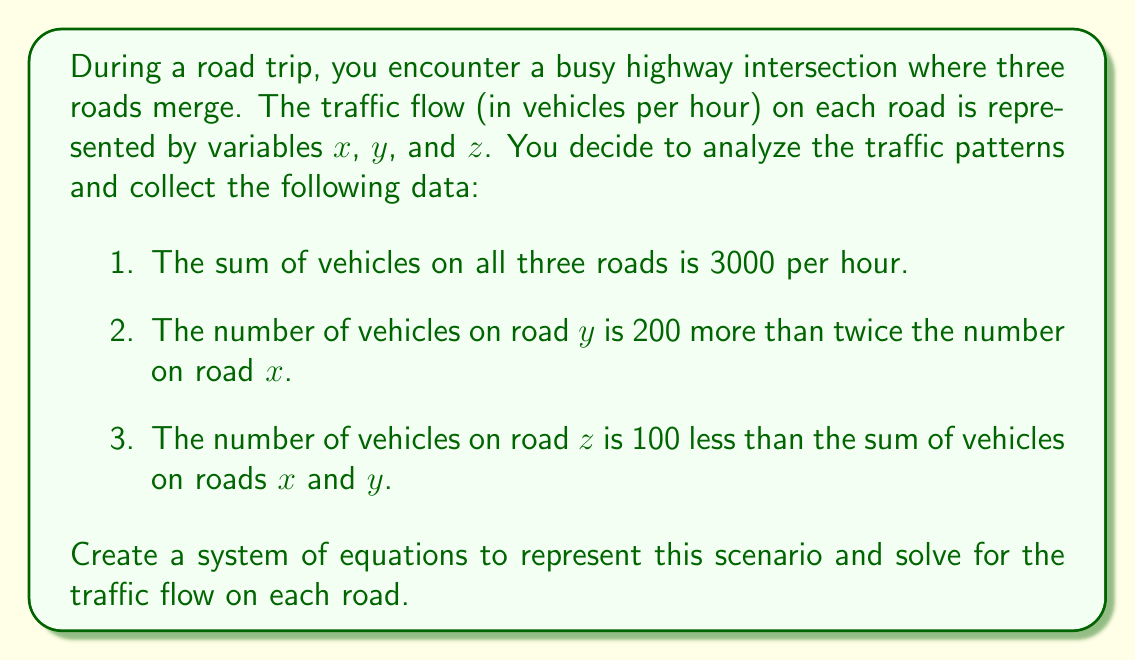Show me your answer to this math problem. Let's approach this step-by-step:

1) First, we'll set up our system of equations based on the given information:

   Equation 1: $x + y + z = 3000$ (total vehicles per hour)
   Equation 2: $y = 2x + 200$ (relationship between $y$ and $x$)
   Equation 3: $z = x + y - 100$ (relationship between $z$, $x$, and $y$)

2) We can solve this system by substitution. Let's start by substituting equation 2 into equation 1:

   $x + (2x + 200) + z = 3000$
   $3x + 200 + z = 3000$

3) Now, let's substitute equation 3 into this new equation:

   $3x + 200 + (x + y - 100) = 3000$
   $3x + 200 + (x + (2x + 200) - 100) = 3000$
   $3x + 200 + 3x + 100 = 3000$
   $6x + 300 = 3000$
   $6x = 2700$
   $x = 450$

4) Now that we know $x$, we can find $y$ using equation 2:

   $y = 2x + 200 = 2(450) + 200 = 1100$

5) Finally, we can find $z$ using equation 3:

   $z = x + y - 100 = 450 + 1100 - 100 = 1450$

6) Let's verify our solution satisfies all equations:

   Equation 1: $450 + 1100 + 1450 = 3000$ ✓
   Equation 2: $1100 = 2(450) + 200$ ✓
   Equation 3: $1450 = 450 + 1100 - 100$ ✓
Answer: The traffic flow on each road is:
Road $x$: 450 vehicles per hour
Road $y$: 1100 vehicles per hour
Road $z$: 1450 vehicles per hour 